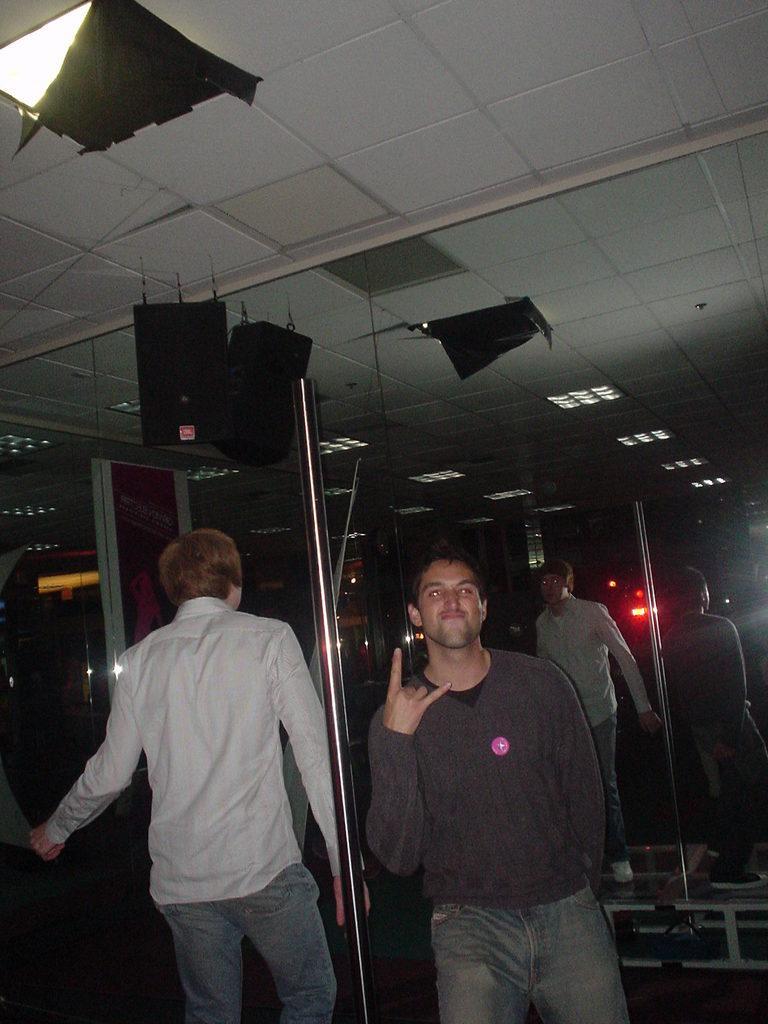Can you describe this image briefly? In this image we can see two persons are standing here. Here we can see mirrors, some objects fixed to the ceiling and the background of the image is dark. 